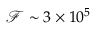<formula> <loc_0><loc_0><loc_500><loc_500>\mathcal { F } \sim 3 \times 1 0 ^ { 5 }</formula> 